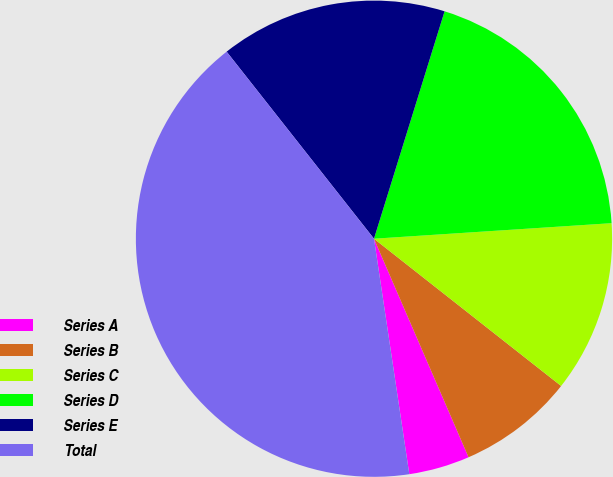Convert chart. <chart><loc_0><loc_0><loc_500><loc_500><pie_chart><fcel>Series A<fcel>Series B<fcel>Series C<fcel>Series D<fcel>Series E<fcel>Total<nl><fcel>4.13%<fcel>7.89%<fcel>11.65%<fcel>19.17%<fcel>15.41%<fcel>41.75%<nl></chart> 